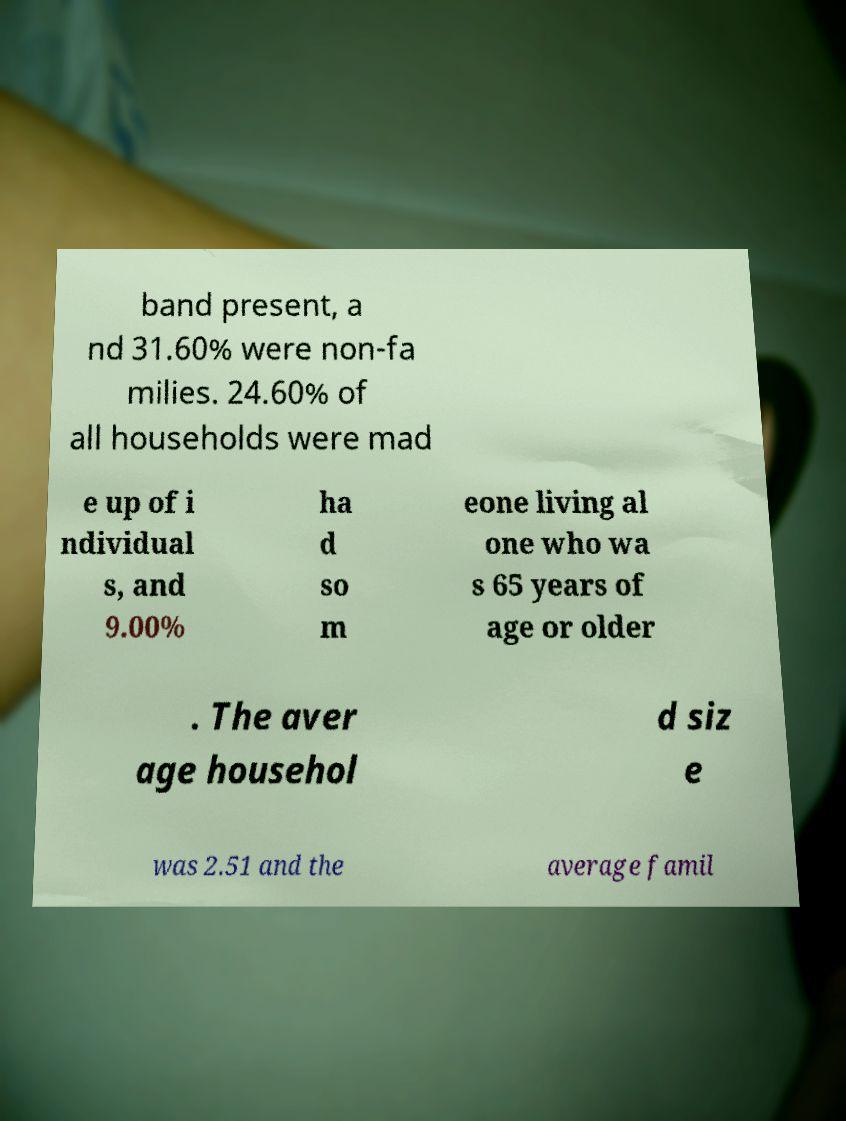I need the written content from this picture converted into text. Can you do that? band present, a nd 31.60% were non-fa milies. 24.60% of all households were mad e up of i ndividual s, and 9.00% ha d so m eone living al one who wa s 65 years of age or older . The aver age househol d siz e was 2.51 and the average famil 